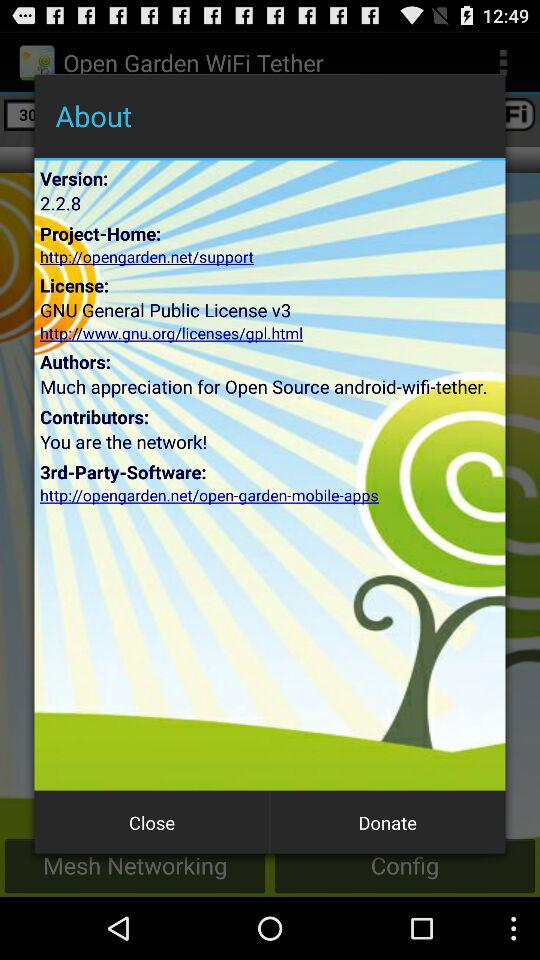What is the web address of "Project-Home"? The web address is "http://opengarden.net/support". 